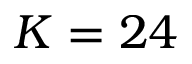Convert formula to latex. <formula><loc_0><loc_0><loc_500><loc_500>K = 2 4</formula> 